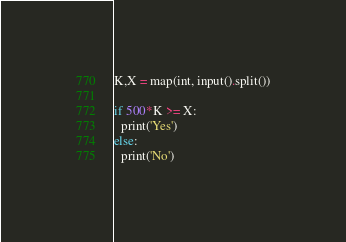Convert code to text. <code><loc_0><loc_0><loc_500><loc_500><_Python_>K,X = map(int, input().split())

if 500*K >= X:
  print('Yes')
else:
  print('No')</code> 